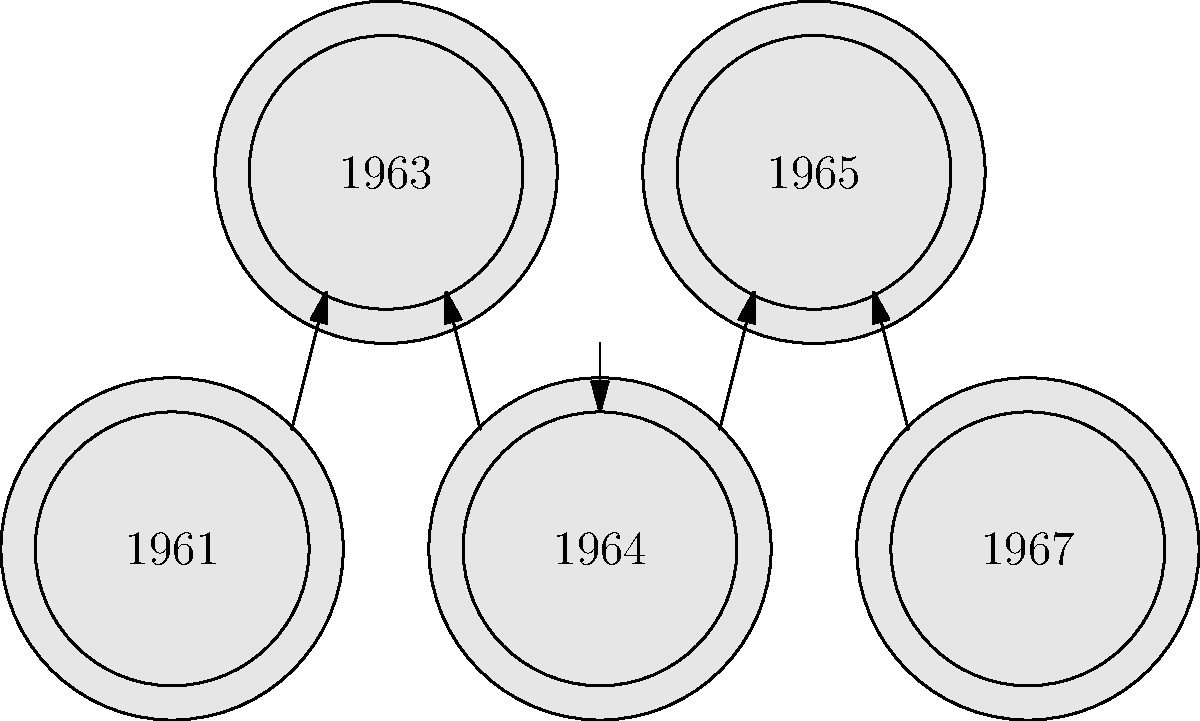Arrange the film reels of 1960s crime thrillers in chronological order based on their visual designs. Which year should be placed in the middle position? To arrange the film reels in chronological order, we need to follow these steps:

1. Identify the years on the film reels: 1961, 1964, 1967, 1963, and 1965.

2. Sort these years in ascending order:
   1961 < 1963 < 1964 < 1965 < 1967

3. Determine the correct arrangement:
   - First position: 1961
   - Second position: 1963
   - Third (middle) position: 1964
   - Fourth position: 1965
   - Fifth position: 1967

4. The question asks for the year in the middle position, which is 1964.

This arrangement reflects the chronological order of the crime thrillers from the 1960s, which would be familiar to a cinema enthusiast like Klaus who has a special fondness for this genre and era.
Answer: 1964 